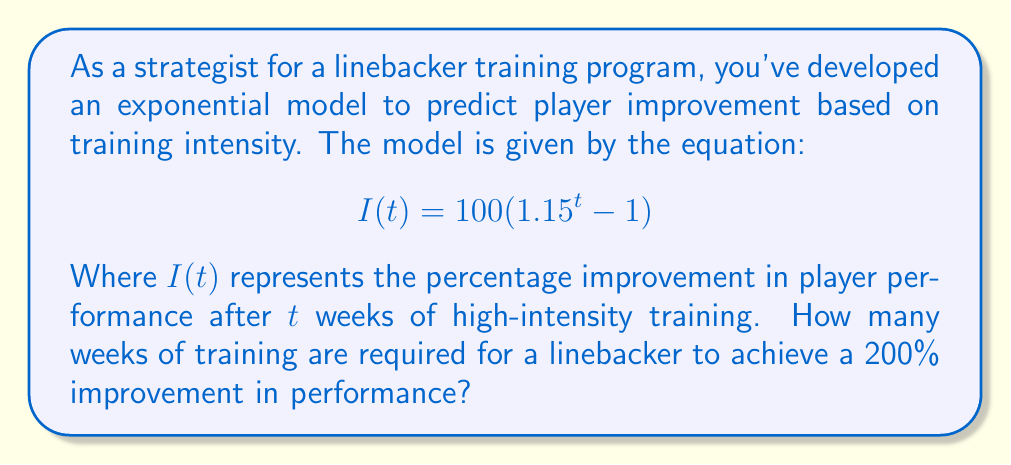Can you solve this math problem? To solve this problem, we need to use the given exponential model and solve for $t$ when $I(t) = 200$. Let's break it down step by step:

1) We start with the equation:
   $$I(t) = 100(1.15^t - 1)$$

2) We want to find $t$ when $I(t) = 200$, so we substitute this:
   $$200 = 100(1.15^t - 1)$$

3) Divide both sides by 100:
   $$2 = 1.15^t - 1$$

4) Add 1 to both sides:
   $$3 = 1.15^t$$

5) Take the natural logarithm of both sides:
   $$\ln(3) = \ln(1.15^t)$$

6) Use the logarithm property $\ln(a^b) = b\ln(a)$:
   $$\ln(3) = t\ln(1.15)$$

7) Solve for $t$ by dividing both sides by $\ln(1.15)$:
   $$t = \frac{\ln(3)}{\ln(1.15)}$$

8) Use a calculator to evaluate this:
   $$t \approx 7.85$$

9) Since we can't have a fractional number of weeks, we round up to the nearest whole number.
Answer: 8 weeks 